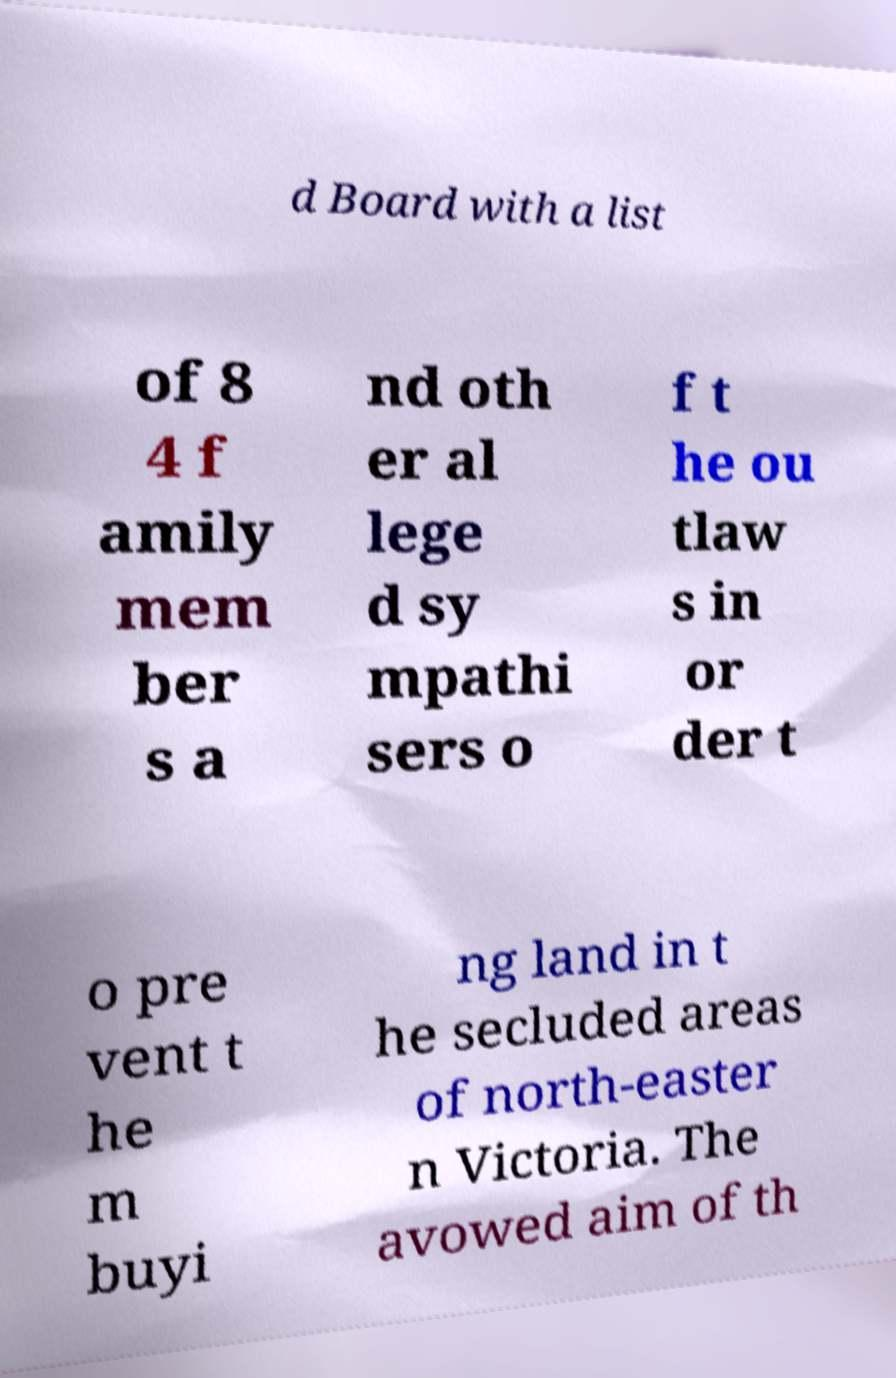Please read and relay the text visible in this image. What does it say? d Board with a list of 8 4 f amily mem ber s a nd oth er al lege d sy mpathi sers o f t he ou tlaw s in or der t o pre vent t he m buyi ng land in t he secluded areas of north-easter n Victoria. The avowed aim of th 